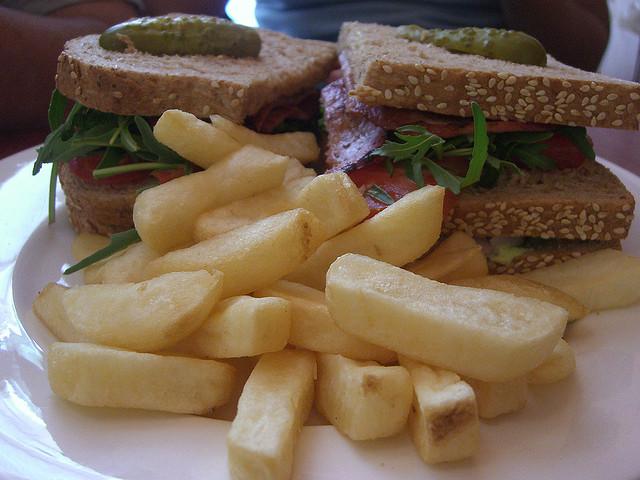Is this meal appropriate for someone with a gluten sensitivity?
Concise answer only. No. What is on the very top of the slices of bread?
Give a very brief answer. Pickle. What kind of seeds are on the crust of the bread?
Keep it brief. Sesame. 